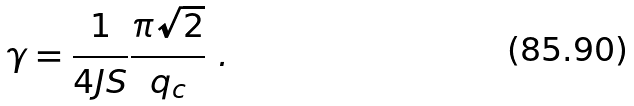Convert formula to latex. <formula><loc_0><loc_0><loc_500><loc_500>\gamma = \frac { 1 } { 4 J S } \frac { \pi \sqrt { 2 } } { q _ { c } } \ .</formula> 